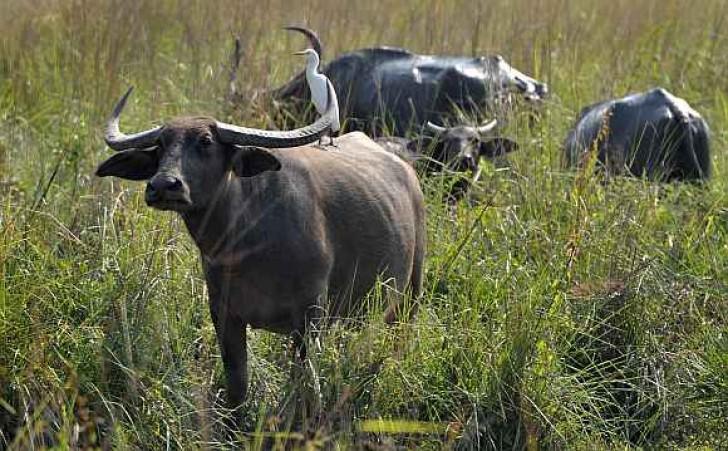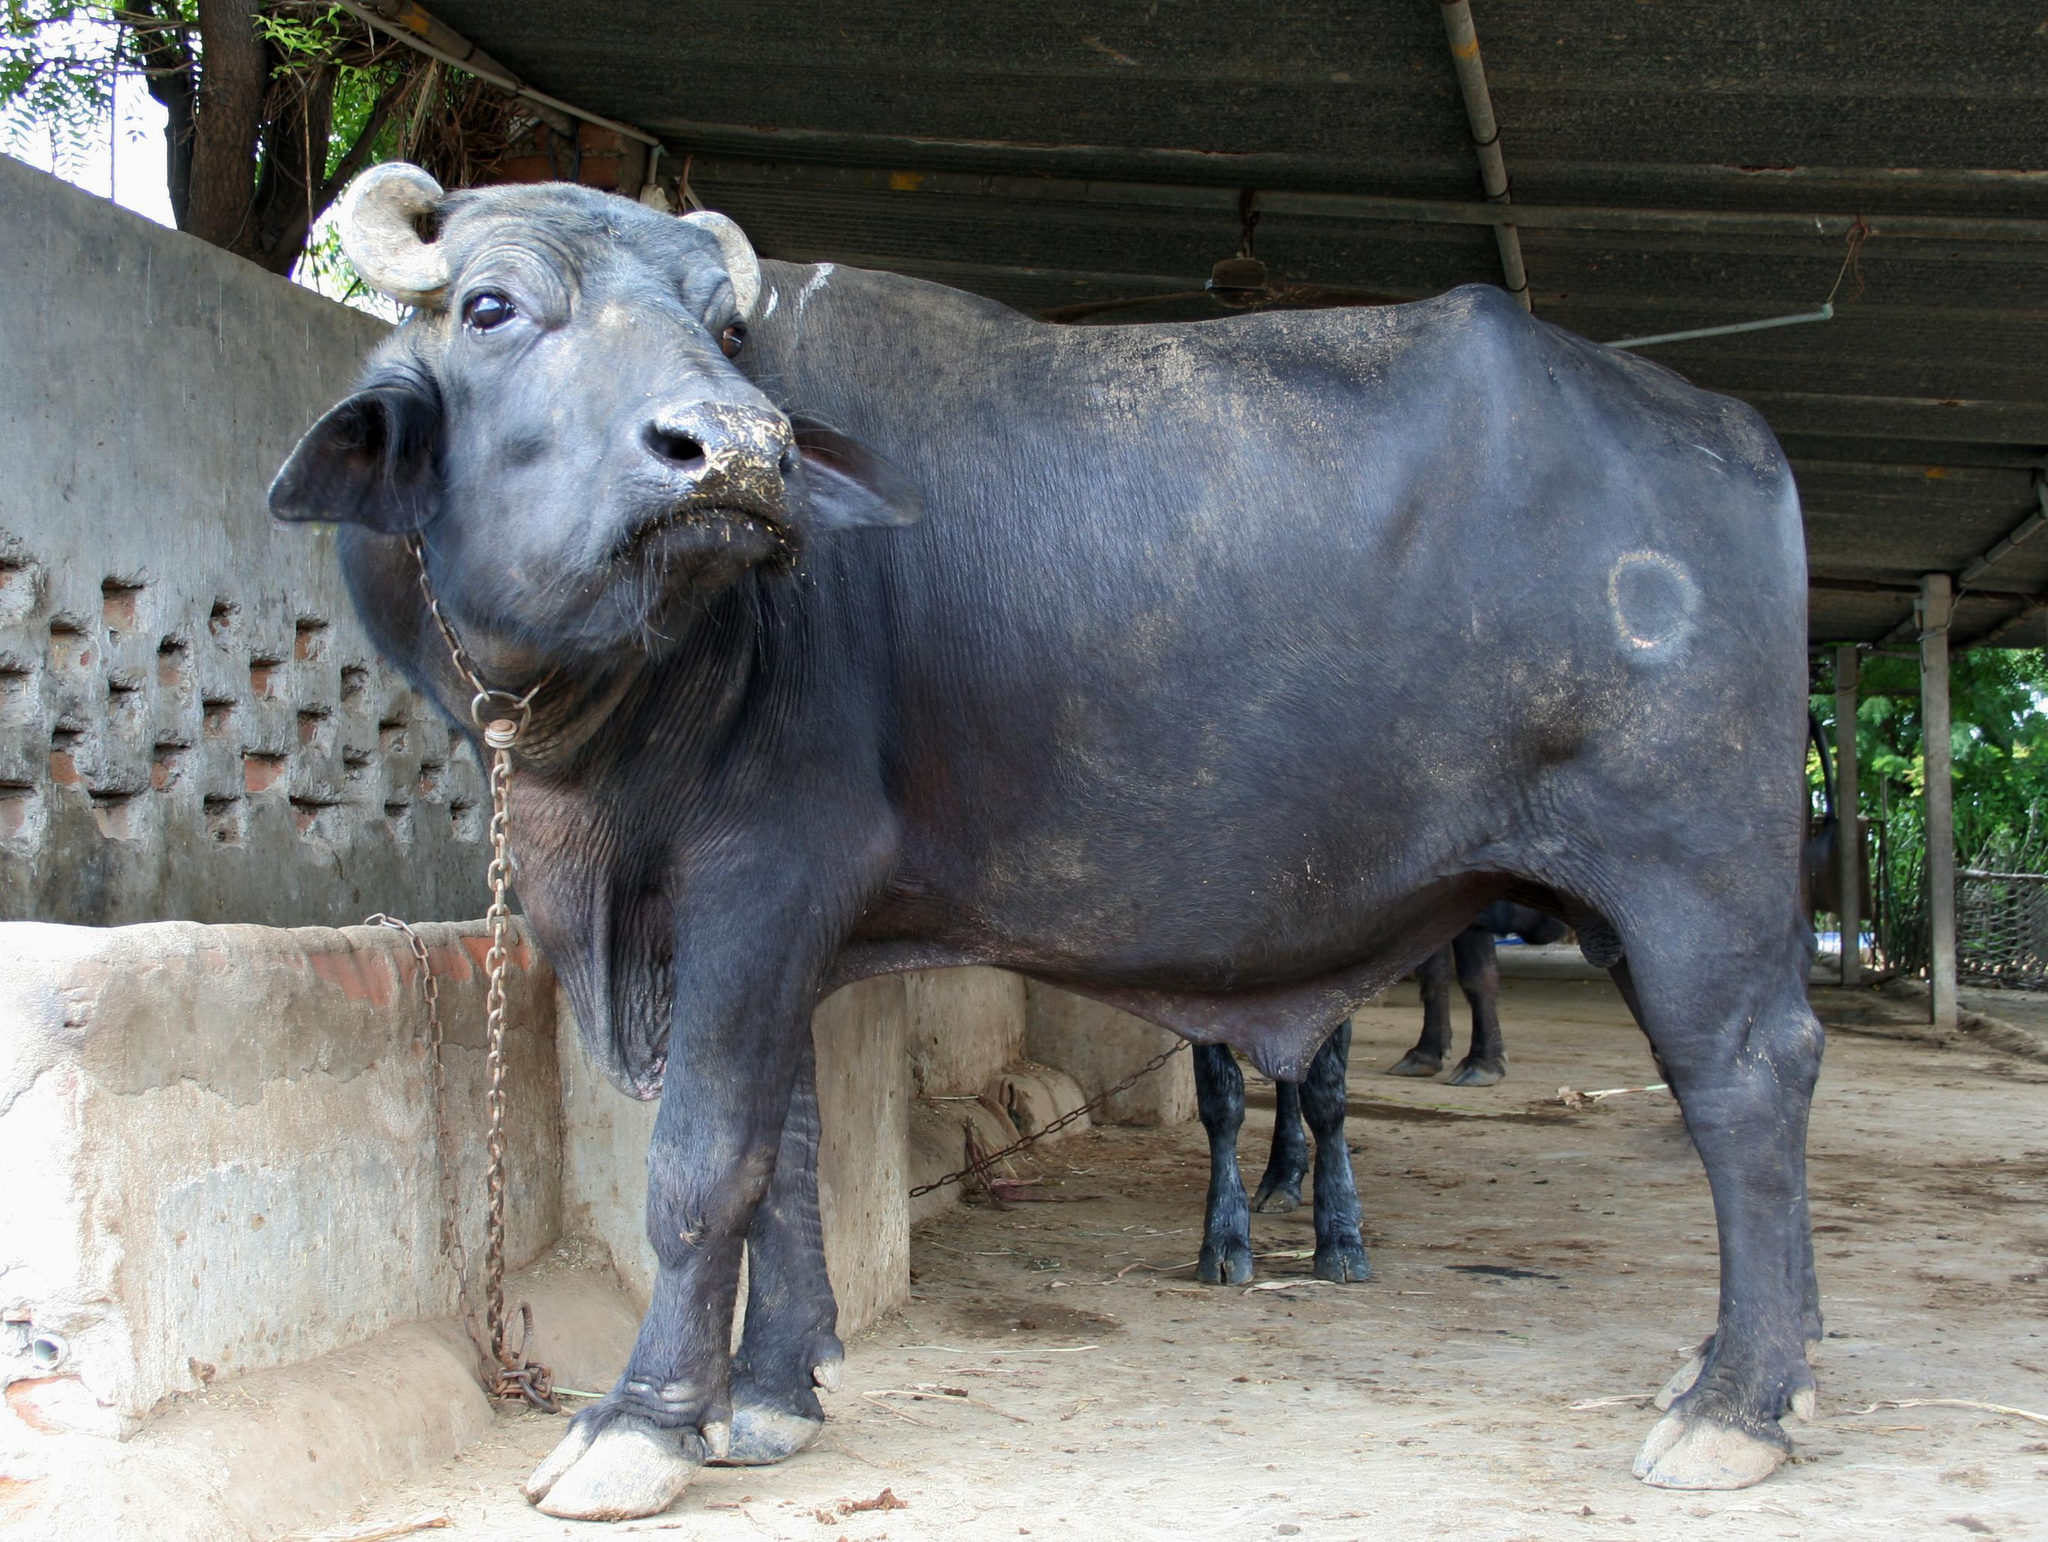The first image is the image on the left, the second image is the image on the right. Examine the images to the left and right. Is the description "The right image contains a dead water buffalo in front of a human." accurate? Answer yes or no. No. The first image is the image on the left, the second image is the image on the right. Examine the images to the left and right. Is the description "A non-standing hunter holding a weapon is behind a killed water buffalo that is lying on the ground with its face forward." accurate? Answer yes or no. No. 